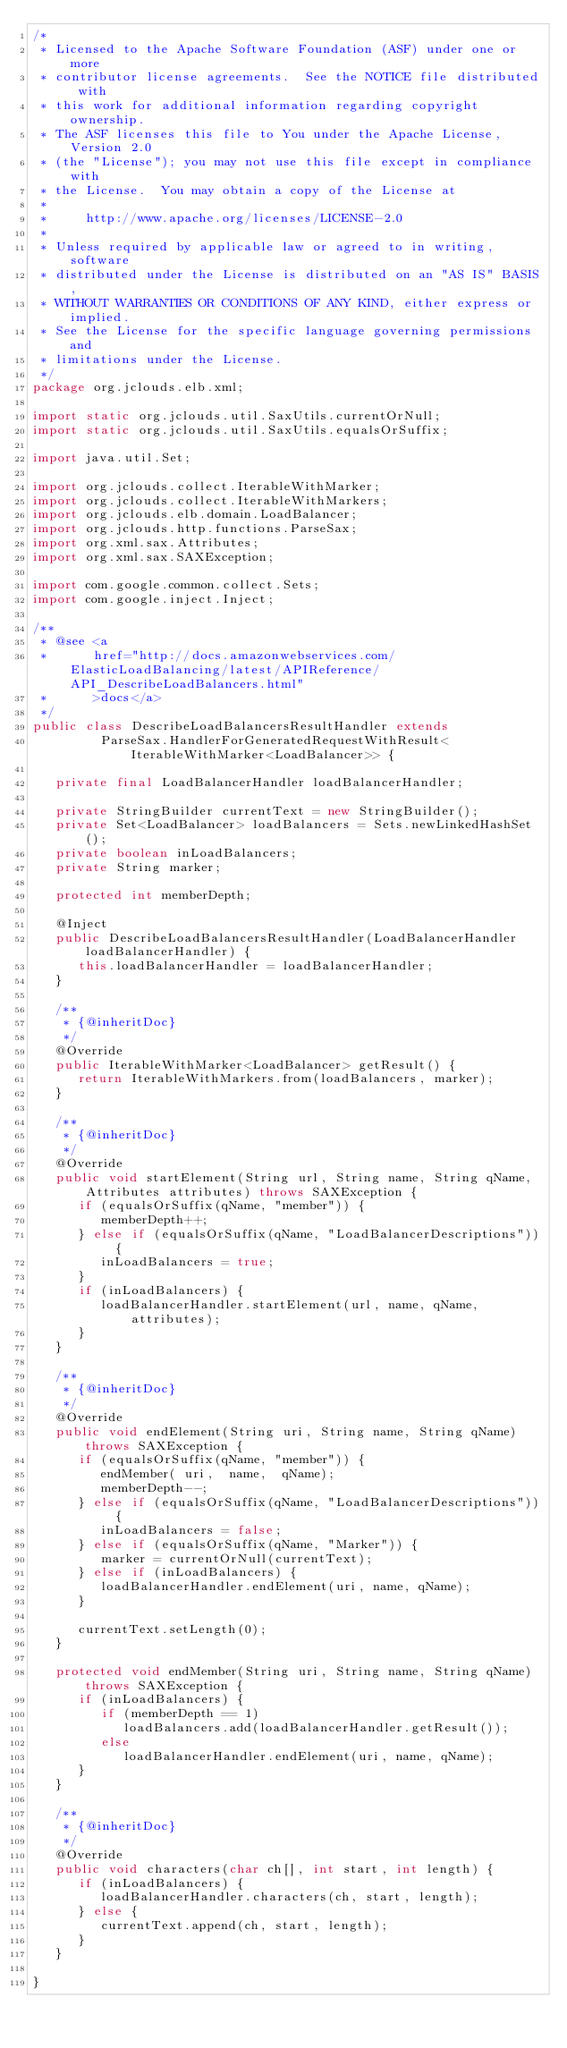Convert code to text. <code><loc_0><loc_0><loc_500><loc_500><_Java_>/*
 * Licensed to the Apache Software Foundation (ASF) under one or more
 * contributor license agreements.  See the NOTICE file distributed with
 * this work for additional information regarding copyright ownership.
 * The ASF licenses this file to You under the Apache License, Version 2.0
 * (the "License"); you may not use this file except in compliance with
 * the License.  You may obtain a copy of the License at
 *
 *     http://www.apache.org/licenses/LICENSE-2.0
 *
 * Unless required by applicable law or agreed to in writing, software
 * distributed under the License is distributed on an "AS IS" BASIS,
 * WITHOUT WARRANTIES OR CONDITIONS OF ANY KIND, either express or implied.
 * See the License for the specific language governing permissions and
 * limitations under the License.
 */
package org.jclouds.elb.xml;

import static org.jclouds.util.SaxUtils.currentOrNull;
import static org.jclouds.util.SaxUtils.equalsOrSuffix;

import java.util.Set;

import org.jclouds.collect.IterableWithMarker;
import org.jclouds.collect.IterableWithMarkers;
import org.jclouds.elb.domain.LoadBalancer;
import org.jclouds.http.functions.ParseSax;
import org.xml.sax.Attributes;
import org.xml.sax.SAXException;

import com.google.common.collect.Sets;
import com.google.inject.Inject;

/**
 * @see <a
 *      href="http://docs.amazonwebservices.com/ElasticLoadBalancing/latest/APIReference/API_DescribeLoadBalancers.html"
 *      >docs</a>
 */
public class DescribeLoadBalancersResultHandler extends
         ParseSax.HandlerForGeneratedRequestWithResult<IterableWithMarker<LoadBalancer>> {

   private final LoadBalancerHandler loadBalancerHandler;

   private StringBuilder currentText = new StringBuilder();
   private Set<LoadBalancer> loadBalancers = Sets.newLinkedHashSet();
   private boolean inLoadBalancers;
   private String marker;

   protected int memberDepth;

   @Inject
   public DescribeLoadBalancersResultHandler(LoadBalancerHandler loadBalancerHandler) {
      this.loadBalancerHandler = loadBalancerHandler;
   }

   /**
    * {@inheritDoc}
    */
   @Override
   public IterableWithMarker<LoadBalancer> getResult() {
      return IterableWithMarkers.from(loadBalancers, marker);
   }

   /**
    * {@inheritDoc}
    */
   @Override
   public void startElement(String url, String name, String qName, Attributes attributes) throws SAXException {
      if (equalsOrSuffix(qName, "member")) {
         memberDepth++;
      } else if (equalsOrSuffix(qName, "LoadBalancerDescriptions")) {
         inLoadBalancers = true;
      }
      if (inLoadBalancers) {
         loadBalancerHandler.startElement(url, name, qName, attributes);
      }
   }

   /**
    * {@inheritDoc}
    */
   @Override
   public void endElement(String uri, String name, String qName) throws SAXException {
      if (equalsOrSuffix(qName, "member")) {
         endMember( uri,  name,  qName);
         memberDepth--;
      } else if (equalsOrSuffix(qName, "LoadBalancerDescriptions")) {
         inLoadBalancers = false;
      } else if (equalsOrSuffix(qName, "Marker")) {
         marker = currentOrNull(currentText);
      } else if (inLoadBalancers) {
         loadBalancerHandler.endElement(uri, name, qName);
      }

      currentText.setLength(0);
   }

   protected void endMember(String uri, String name, String qName) throws SAXException {
      if (inLoadBalancers) {
         if (memberDepth == 1)
            loadBalancers.add(loadBalancerHandler.getResult());
         else
            loadBalancerHandler.endElement(uri, name, qName);
      }
   }

   /**
    * {@inheritDoc}
    */
   @Override
   public void characters(char ch[], int start, int length) {
      if (inLoadBalancers) {
         loadBalancerHandler.characters(ch, start, length);
      } else {
         currentText.append(ch, start, length);
      }
   }

}
</code> 